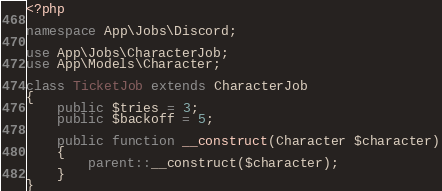<code> <loc_0><loc_0><loc_500><loc_500><_PHP_><?php

namespace App\Jobs\Discord;

use App\Jobs\CharacterJob;
use App\Models\Character;

class TicketJob extends CharacterJob
{
    public $tries = 3;
    public $backoff = 5;

    public function __construct(Character $character)
    {
        parent::__construct($character);
    }
}
</code> 